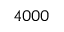<formula> <loc_0><loc_0><loc_500><loc_500>4 0 0 0</formula> 